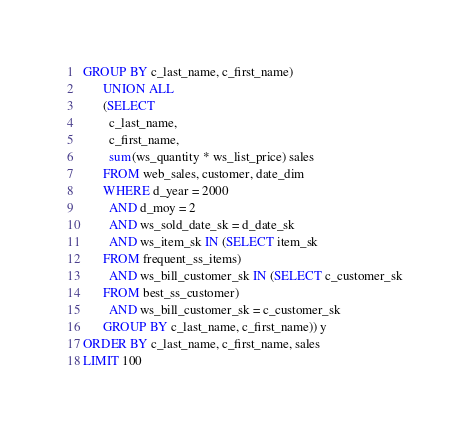<code> <loc_0><loc_0><loc_500><loc_500><_SQL_>GROUP BY c_last_name, c_first_name)
      UNION ALL
      (SELECT
        c_last_name,
        c_first_name,
        sum(ws_quantity * ws_list_price) sales
      FROM web_sales, customer, date_dim
      WHERE d_year = 2000
        AND d_moy = 2
        AND ws_sold_date_sk = d_date_sk
        AND ws_item_sk IN (SELECT item_sk
      FROM frequent_ss_items)
        AND ws_bill_customer_sk IN (SELECT c_customer_sk
      FROM best_ss_customer)
        AND ws_bill_customer_sk = c_customer_sk
      GROUP BY c_last_name, c_first_name)) y
ORDER BY c_last_name, c_first_name, sales
LIMIT 100
</code> 